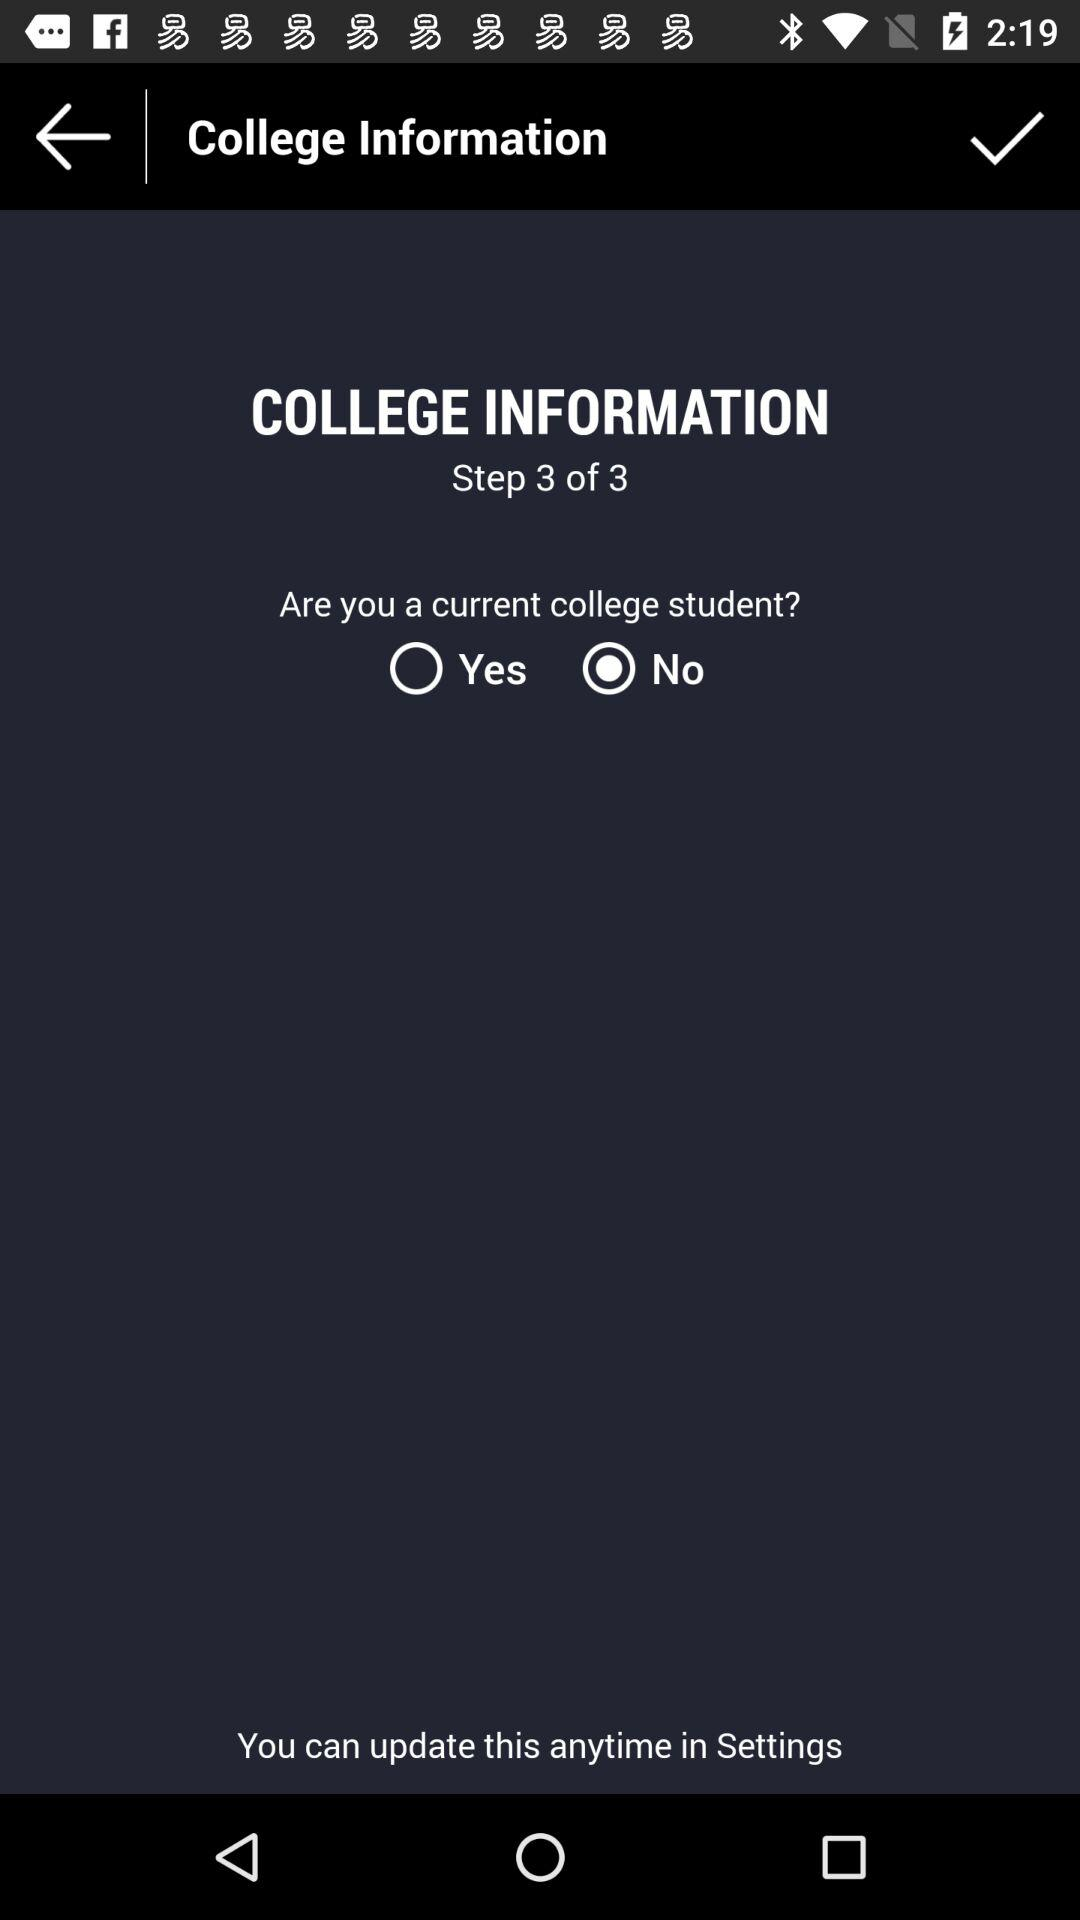What is the current step? The current step is 3. 